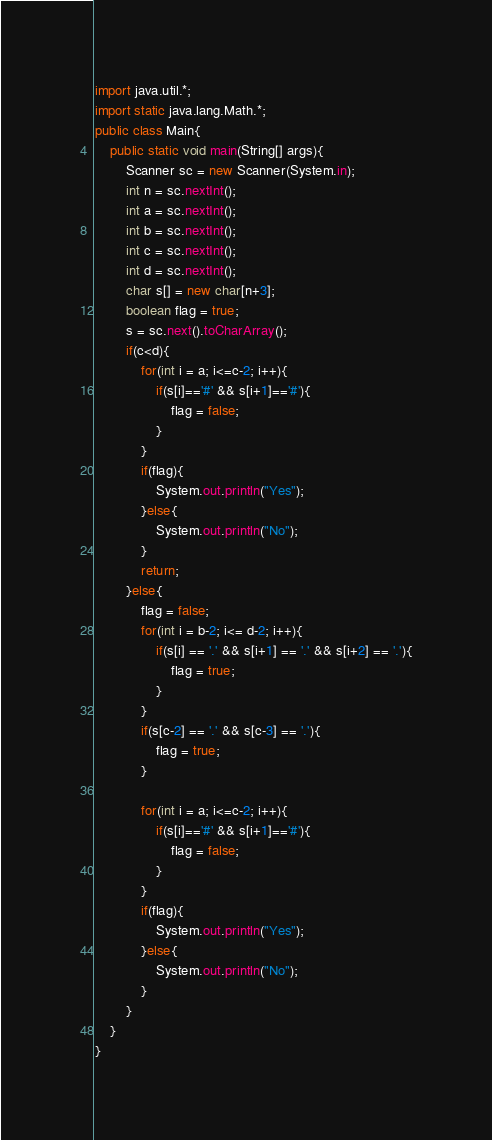<code> <loc_0><loc_0><loc_500><loc_500><_Java_>import java.util.*;
import static java.lang.Math.*;
public class Main{
    public static void main(String[] args){
        Scanner sc = new Scanner(System.in);
        int n = sc.nextInt();
        int a = sc.nextInt();
        int b = sc.nextInt();
        int c = sc.nextInt();
        int d = sc.nextInt();
        char s[] = new char[n+3];
        boolean flag = true;
        s = sc.next().toCharArray();
        if(c<d){
            for(int i = a; i<=c-2; i++){
                if(s[i]=='#' && s[i+1]=='#'){
                    flag = false;
                }
            }
            if(flag){
                System.out.println("Yes");
            }else{
                System.out.println("No");
            }
            return;
        }else{
            flag = false;
            for(int i = b-2; i<= d-2; i++){
                if(s[i] == '.' && s[i+1] == '.' && s[i+2] == '.'){
                    flag = true;
                }
            }
            if(s[c-2] == '.' && s[c-3] == '.'){
                flag = true;
            }

            for(int i = a; i<=c-2; i++){
                if(s[i]=='#' && s[i+1]=='#'){
                    flag = false;
                }
            }
            if(flag){
                System.out.println("Yes");
            }else{
                System.out.println("No");
            }
        }  
    }
}
</code> 